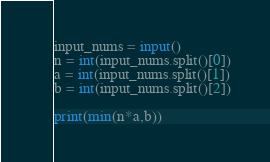Convert code to text. <code><loc_0><loc_0><loc_500><loc_500><_Python_>input_nums = input()
n = int(input_nums.split()[0])
a = int(input_nums.split()[1])
b = int(input_nums.split()[2])

print(min(n*a,b))
</code> 